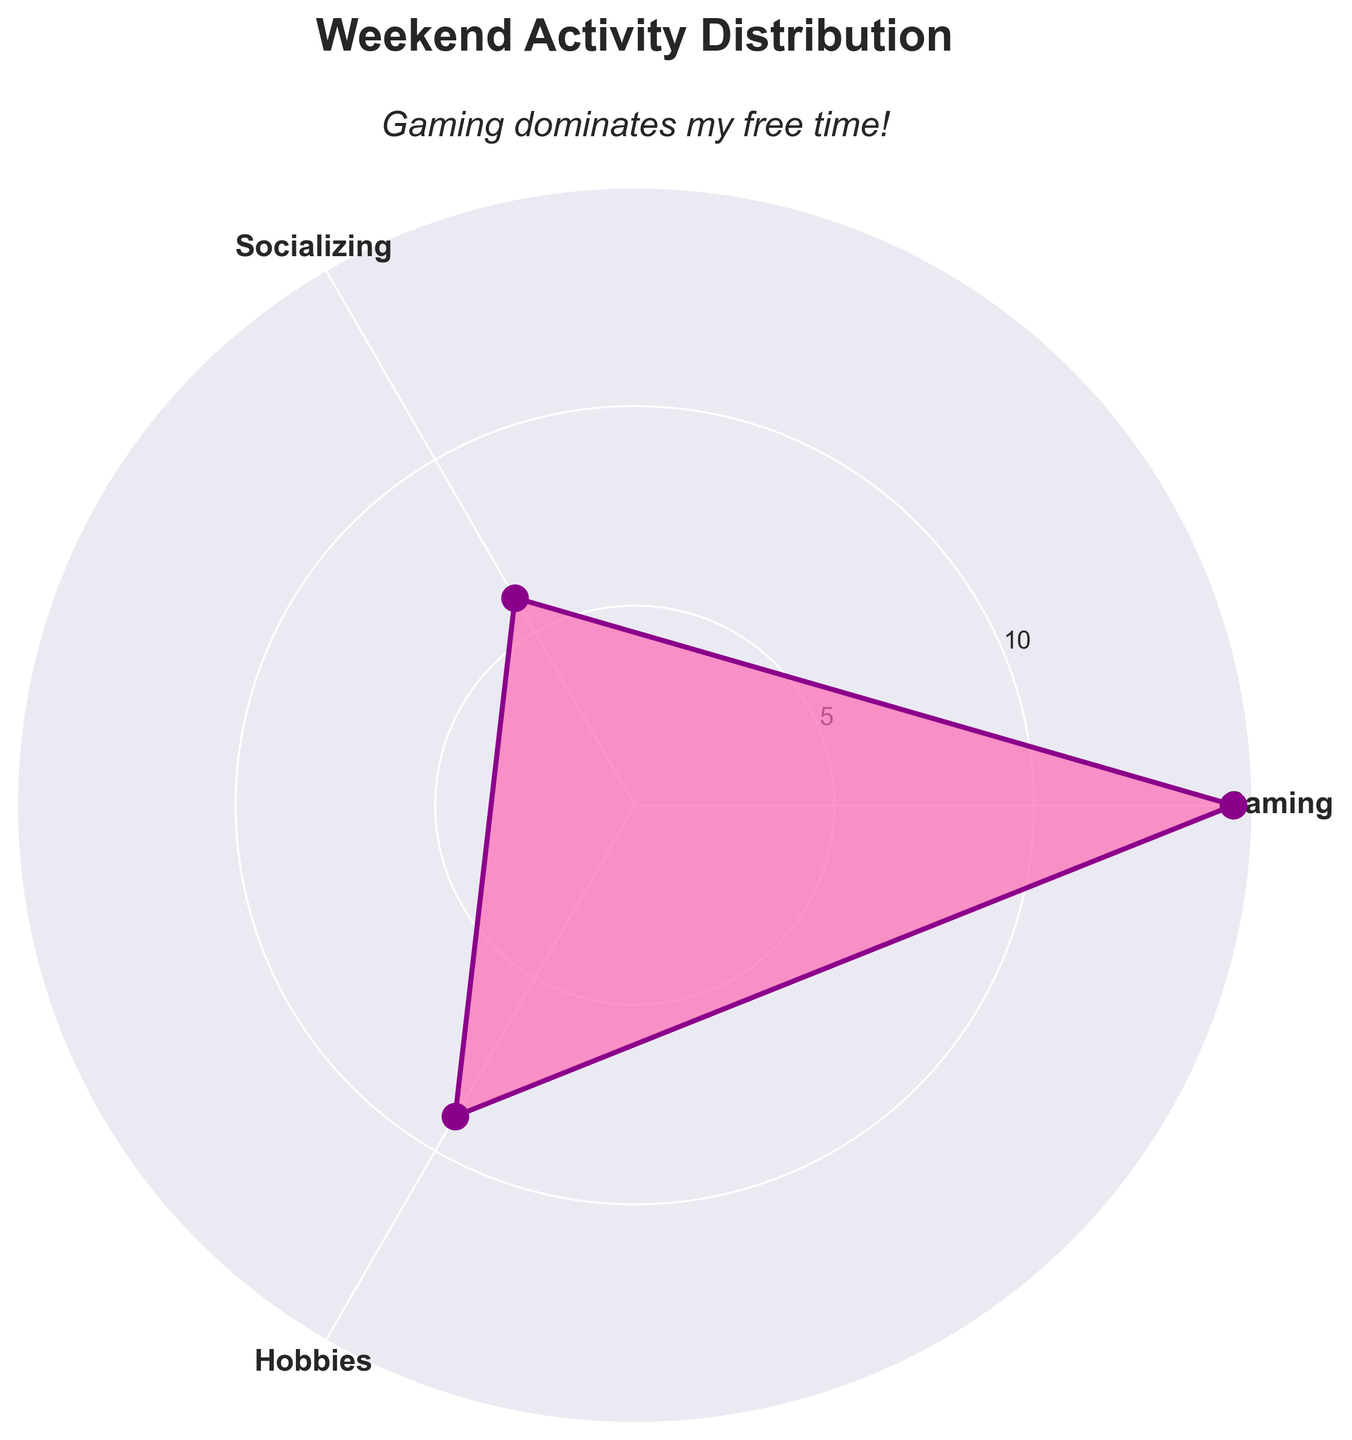What's the title of the rose chart? The title of the rose chart is present at the top center of the figure. It explicitly states what the chart represents.
Answer: Weekend Activity Distribution Which activity has the highest number of hours? The activity with the greatest radial distance (longest section) in the chart is the one with the highest number of hours.
Answer: Gaming What color is used to fill the rose chart? Observing the interior of the plotted area, the color filling the sections of the rose chart is identifiable.
Answer: Pink How many hours are spent on socializing and hobbies combined? Adding the hours spent on socializing (6) and hobbies (9) gives the total hours spent on both activities.
Answer: 15 How much more time is spent on gaming than on socializing? Subtract the hours spent on socializing (6) from the hours spent on gaming (15) to find the difference.
Answer: 9 Rank the activities from the least to the most hours spent. Observing the radial lengths associated with each activity allows ordering them from shortest to longest.
Answer: Socializing < Hobbies < Gaming How does the title describe your preference in activities? The subtitle beneath the main title provides additional information on the interpretation of the time distribution.
Answer: Gaming dominates my free time! What is the average number of hours spent on all activities? Summing the hours spent on all activities (15 for gaming, 6 for socializing, and 9 for hobbies) and then dividing by the number of activities (3) yields the average.
Answer: 10 Which activity is the second most time-consuming? By comparing the radial lengths of each activity, the activity with the second longest section represents the second most time-consuming activity.
Answer: Hobbies How much time is spent on activities other than gaming? Summing the hours of socializing (6) and hobbies (9) gives the total time spent on activities other than gaming.
Answer: 15 